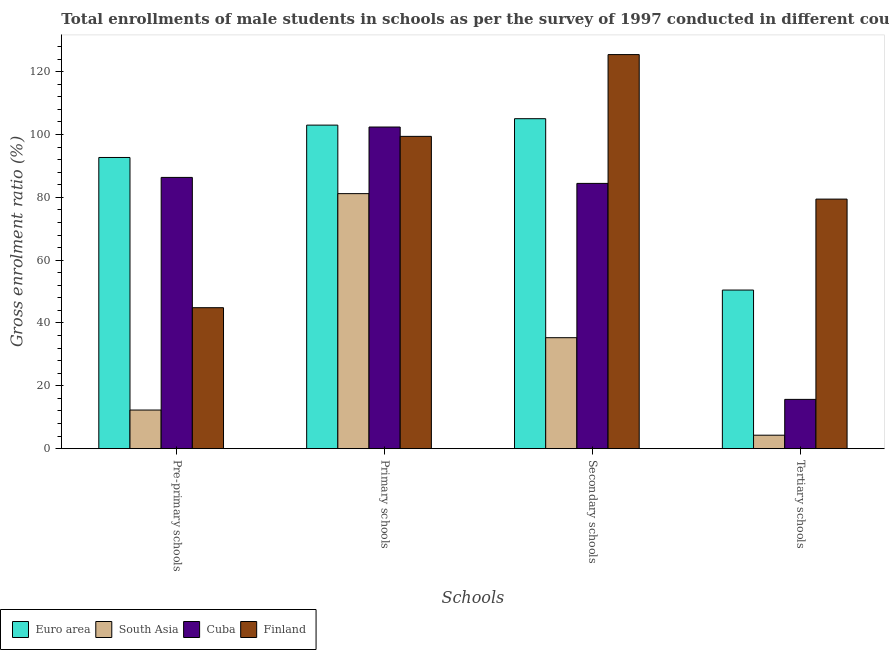Are the number of bars per tick equal to the number of legend labels?
Keep it short and to the point. Yes. Are the number of bars on each tick of the X-axis equal?
Offer a very short reply. Yes. How many bars are there on the 3rd tick from the right?
Offer a very short reply. 4. What is the label of the 4th group of bars from the left?
Keep it short and to the point. Tertiary schools. What is the gross enrolment ratio(male) in tertiary schools in Cuba?
Your answer should be compact. 15.69. Across all countries, what is the maximum gross enrolment ratio(male) in secondary schools?
Make the answer very short. 125.43. Across all countries, what is the minimum gross enrolment ratio(male) in primary schools?
Offer a terse response. 81.18. What is the total gross enrolment ratio(male) in pre-primary schools in the graph?
Your answer should be very brief. 236.18. What is the difference between the gross enrolment ratio(male) in primary schools in Euro area and that in Cuba?
Your response must be concise. 0.61. What is the difference between the gross enrolment ratio(male) in tertiary schools in Finland and the gross enrolment ratio(male) in primary schools in South Asia?
Provide a short and direct response. -1.74. What is the average gross enrolment ratio(male) in pre-primary schools per country?
Provide a short and direct response. 59.05. What is the difference between the gross enrolment ratio(male) in secondary schools and gross enrolment ratio(male) in primary schools in Euro area?
Provide a succinct answer. 2.04. What is the ratio of the gross enrolment ratio(male) in secondary schools in Finland to that in Cuba?
Make the answer very short. 1.49. Is the difference between the gross enrolment ratio(male) in secondary schools in Finland and South Asia greater than the difference between the gross enrolment ratio(male) in primary schools in Finland and South Asia?
Ensure brevity in your answer.  Yes. What is the difference between the highest and the second highest gross enrolment ratio(male) in secondary schools?
Offer a very short reply. 20.41. What is the difference between the highest and the lowest gross enrolment ratio(male) in secondary schools?
Provide a short and direct response. 90.11. Is the sum of the gross enrolment ratio(male) in tertiary schools in South Asia and Finland greater than the maximum gross enrolment ratio(male) in primary schools across all countries?
Ensure brevity in your answer.  No. Is it the case that in every country, the sum of the gross enrolment ratio(male) in secondary schools and gross enrolment ratio(male) in pre-primary schools is greater than the sum of gross enrolment ratio(male) in primary schools and gross enrolment ratio(male) in tertiary schools?
Provide a succinct answer. No. What does the 3rd bar from the left in Pre-primary schools represents?
Provide a short and direct response. Cuba. What does the 2nd bar from the right in Secondary schools represents?
Provide a succinct answer. Cuba. Are all the bars in the graph horizontal?
Your answer should be compact. No. How many countries are there in the graph?
Ensure brevity in your answer.  4. What is the difference between two consecutive major ticks on the Y-axis?
Your answer should be very brief. 20. Does the graph contain any zero values?
Give a very brief answer. No. Where does the legend appear in the graph?
Keep it short and to the point. Bottom left. How many legend labels are there?
Provide a short and direct response. 4. How are the legend labels stacked?
Your answer should be compact. Horizontal. What is the title of the graph?
Your response must be concise. Total enrollments of male students in schools as per the survey of 1997 conducted in different countries. What is the label or title of the X-axis?
Your answer should be very brief. Schools. What is the label or title of the Y-axis?
Your response must be concise. Gross enrolment ratio (%). What is the Gross enrolment ratio (%) of Euro area in Pre-primary schools?
Give a very brief answer. 92.68. What is the Gross enrolment ratio (%) of South Asia in Pre-primary schools?
Your answer should be compact. 12.29. What is the Gross enrolment ratio (%) of Cuba in Pre-primary schools?
Offer a terse response. 86.34. What is the Gross enrolment ratio (%) in Finland in Pre-primary schools?
Provide a short and direct response. 44.87. What is the Gross enrolment ratio (%) in Euro area in Primary schools?
Offer a terse response. 102.98. What is the Gross enrolment ratio (%) of South Asia in Primary schools?
Your response must be concise. 81.18. What is the Gross enrolment ratio (%) in Cuba in Primary schools?
Offer a terse response. 102.38. What is the Gross enrolment ratio (%) of Finland in Primary schools?
Provide a succinct answer. 99.4. What is the Gross enrolment ratio (%) of Euro area in Secondary schools?
Provide a succinct answer. 105.03. What is the Gross enrolment ratio (%) in South Asia in Secondary schools?
Offer a terse response. 35.32. What is the Gross enrolment ratio (%) in Cuba in Secondary schools?
Offer a very short reply. 84.43. What is the Gross enrolment ratio (%) in Finland in Secondary schools?
Your response must be concise. 125.43. What is the Gross enrolment ratio (%) of Euro area in Tertiary schools?
Ensure brevity in your answer.  50.49. What is the Gross enrolment ratio (%) in South Asia in Tertiary schools?
Give a very brief answer. 4.29. What is the Gross enrolment ratio (%) of Cuba in Tertiary schools?
Provide a succinct answer. 15.69. What is the Gross enrolment ratio (%) of Finland in Tertiary schools?
Give a very brief answer. 79.43. Across all Schools, what is the maximum Gross enrolment ratio (%) of Euro area?
Offer a very short reply. 105.03. Across all Schools, what is the maximum Gross enrolment ratio (%) in South Asia?
Ensure brevity in your answer.  81.18. Across all Schools, what is the maximum Gross enrolment ratio (%) in Cuba?
Provide a short and direct response. 102.38. Across all Schools, what is the maximum Gross enrolment ratio (%) in Finland?
Your answer should be very brief. 125.43. Across all Schools, what is the minimum Gross enrolment ratio (%) in Euro area?
Your response must be concise. 50.49. Across all Schools, what is the minimum Gross enrolment ratio (%) in South Asia?
Provide a short and direct response. 4.29. Across all Schools, what is the minimum Gross enrolment ratio (%) in Cuba?
Give a very brief answer. 15.69. Across all Schools, what is the minimum Gross enrolment ratio (%) in Finland?
Offer a terse response. 44.87. What is the total Gross enrolment ratio (%) of Euro area in the graph?
Provide a succinct answer. 351.17. What is the total Gross enrolment ratio (%) of South Asia in the graph?
Ensure brevity in your answer.  133.09. What is the total Gross enrolment ratio (%) in Cuba in the graph?
Ensure brevity in your answer.  288.83. What is the total Gross enrolment ratio (%) in Finland in the graph?
Your answer should be very brief. 349.14. What is the difference between the Gross enrolment ratio (%) of Euro area in Pre-primary schools and that in Primary schools?
Your response must be concise. -10.3. What is the difference between the Gross enrolment ratio (%) of South Asia in Pre-primary schools and that in Primary schools?
Give a very brief answer. -68.88. What is the difference between the Gross enrolment ratio (%) of Cuba in Pre-primary schools and that in Primary schools?
Your response must be concise. -16.04. What is the difference between the Gross enrolment ratio (%) in Finland in Pre-primary schools and that in Primary schools?
Offer a terse response. -54.53. What is the difference between the Gross enrolment ratio (%) in Euro area in Pre-primary schools and that in Secondary schools?
Your response must be concise. -12.34. What is the difference between the Gross enrolment ratio (%) of South Asia in Pre-primary schools and that in Secondary schools?
Offer a very short reply. -23.03. What is the difference between the Gross enrolment ratio (%) of Cuba in Pre-primary schools and that in Secondary schools?
Ensure brevity in your answer.  1.91. What is the difference between the Gross enrolment ratio (%) of Finland in Pre-primary schools and that in Secondary schools?
Provide a succinct answer. -80.56. What is the difference between the Gross enrolment ratio (%) in Euro area in Pre-primary schools and that in Tertiary schools?
Provide a short and direct response. 42.2. What is the difference between the Gross enrolment ratio (%) of South Asia in Pre-primary schools and that in Tertiary schools?
Offer a very short reply. 8. What is the difference between the Gross enrolment ratio (%) in Cuba in Pre-primary schools and that in Tertiary schools?
Offer a terse response. 70.65. What is the difference between the Gross enrolment ratio (%) in Finland in Pre-primary schools and that in Tertiary schools?
Ensure brevity in your answer.  -34.56. What is the difference between the Gross enrolment ratio (%) of Euro area in Primary schools and that in Secondary schools?
Keep it short and to the point. -2.04. What is the difference between the Gross enrolment ratio (%) in South Asia in Primary schools and that in Secondary schools?
Offer a very short reply. 45.85. What is the difference between the Gross enrolment ratio (%) of Cuba in Primary schools and that in Secondary schools?
Give a very brief answer. 17.94. What is the difference between the Gross enrolment ratio (%) of Finland in Primary schools and that in Secondary schools?
Ensure brevity in your answer.  -26.03. What is the difference between the Gross enrolment ratio (%) in Euro area in Primary schools and that in Tertiary schools?
Make the answer very short. 52.5. What is the difference between the Gross enrolment ratio (%) of South Asia in Primary schools and that in Tertiary schools?
Ensure brevity in your answer.  76.88. What is the difference between the Gross enrolment ratio (%) of Cuba in Primary schools and that in Tertiary schools?
Make the answer very short. 86.69. What is the difference between the Gross enrolment ratio (%) in Finland in Primary schools and that in Tertiary schools?
Give a very brief answer. 19.97. What is the difference between the Gross enrolment ratio (%) of Euro area in Secondary schools and that in Tertiary schools?
Ensure brevity in your answer.  54.54. What is the difference between the Gross enrolment ratio (%) in South Asia in Secondary schools and that in Tertiary schools?
Keep it short and to the point. 31.03. What is the difference between the Gross enrolment ratio (%) of Cuba in Secondary schools and that in Tertiary schools?
Make the answer very short. 68.74. What is the difference between the Gross enrolment ratio (%) of Finland in Secondary schools and that in Tertiary schools?
Give a very brief answer. 46. What is the difference between the Gross enrolment ratio (%) in Euro area in Pre-primary schools and the Gross enrolment ratio (%) in South Asia in Primary schools?
Offer a very short reply. 11.51. What is the difference between the Gross enrolment ratio (%) of Euro area in Pre-primary schools and the Gross enrolment ratio (%) of Cuba in Primary schools?
Offer a terse response. -9.69. What is the difference between the Gross enrolment ratio (%) of Euro area in Pre-primary schools and the Gross enrolment ratio (%) of Finland in Primary schools?
Ensure brevity in your answer.  -6.72. What is the difference between the Gross enrolment ratio (%) in South Asia in Pre-primary schools and the Gross enrolment ratio (%) in Cuba in Primary schools?
Your response must be concise. -90.08. What is the difference between the Gross enrolment ratio (%) in South Asia in Pre-primary schools and the Gross enrolment ratio (%) in Finland in Primary schools?
Ensure brevity in your answer.  -87.11. What is the difference between the Gross enrolment ratio (%) in Cuba in Pre-primary schools and the Gross enrolment ratio (%) in Finland in Primary schools?
Give a very brief answer. -13.06. What is the difference between the Gross enrolment ratio (%) in Euro area in Pre-primary schools and the Gross enrolment ratio (%) in South Asia in Secondary schools?
Your response must be concise. 57.36. What is the difference between the Gross enrolment ratio (%) in Euro area in Pre-primary schools and the Gross enrolment ratio (%) in Cuba in Secondary schools?
Provide a succinct answer. 8.25. What is the difference between the Gross enrolment ratio (%) in Euro area in Pre-primary schools and the Gross enrolment ratio (%) in Finland in Secondary schools?
Offer a terse response. -32.75. What is the difference between the Gross enrolment ratio (%) of South Asia in Pre-primary schools and the Gross enrolment ratio (%) of Cuba in Secondary schools?
Give a very brief answer. -72.14. What is the difference between the Gross enrolment ratio (%) in South Asia in Pre-primary schools and the Gross enrolment ratio (%) in Finland in Secondary schools?
Provide a short and direct response. -113.14. What is the difference between the Gross enrolment ratio (%) of Cuba in Pre-primary schools and the Gross enrolment ratio (%) of Finland in Secondary schools?
Provide a succinct answer. -39.1. What is the difference between the Gross enrolment ratio (%) in Euro area in Pre-primary schools and the Gross enrolment ratio (%) in South Asia in Tertiary schools?
Make the answer very short. 88.39. What is the difference between the Gross enrolment ratio (%) in Euro area in Pre-primary schools and the Gross enrolment ratio (%) in Cuba in Tertiary schools?
Give a very brief answer. 77. What is the difference between the Gross enrolment ratio (%) of Euro area in Pre-primary schools and the Gross enrolment ratio (%) of Finland in Tertiary schools?
Your response must be concise. 13.25. What is the difference between the Gross enrolment ratio (%) in South Asia in Pre-primary schools and the Gross enrolment ratio (%) in Cuba in Tertiary schools?
Keep it short and to the point. -3.39. What is the difference between the Gross enrolment ratio (%) in South Asia in Pre-primary schools and the Gross enrolment ratio (%) in Finland in Tertiary schools?
Make the answer very short. -67.14. What is the difference between the Gross enrolment ratio (%) in Cuba in Pre-primary schools and the Gross enrolment ratio (%) in Finland in Tertiary schools?
Give a very brief answer. 6.9. What is the difference between the Gross enrolment ratio (%) in Euro area in Primary schools and the Gross enrolment ratio (%) in South Asia in Secondary schools?
Ensure brevity in your answer.  67.66. What is the difference between the Gross enrolment ratio (%) in Euro area in Primary schools and the Gross enrolment ratio (%) in Cuba in Secondary schools?
Your answer should be compact. 18.55. What is the difference between the Gross enrolment ratio (%) in Euro area in Primary schools and the Gross enrolment ratio (%) in Finland in Secondary schools?
Give a very brief answer. -22.45. What is the difference between the Gross enrolment ratio (%) in South Asia in Primary schools and the Gross enrolment ratio (%) in Cuba in Secondary schools?
Ensure brevity in your answer.  -3.25. What is the difference between the Gross enrolment ratio (%) of South Asia in Primary schools and the Gross enrolment ratio (%) of Finland in Secondary schools?
Your response must be concise. -44.26. What is the difference between the Gross enrolment ratio (%) of Cuba in Primary schools and the Gross enrolment ratio (%) of Finland in Secondary schools?
Give a very brief answer. -23.06. What is the difference between the Gross enrolment ratio (%) in Euro area in Primary schools and the Gross enrolment ratio (%) in South Asia in Tertiary schools?
Make the answer very short. 98.69. What is the difference between the Gross enrolment ratio (%) in Euro area in Primary schools and the Gross enrolment ratio (%) in Cuba in Tertiary schools?
Offer a terse response. 87.29. What is the difference between the Gross enrolment ratio (%) in Euro area in Primary schools and the Gross enrolment ratio (%) in Finland in Tertiary schools?
Ensure brevity in your answer.  23.55. What is the difference between the Gross enrolment ratio (%) in South Asia in Primary schools and the Gross enrolment ratio (%) in Cuba in Tertiary schools?
Keep it short and to the point. 65.49. What is the difference between the Gross enrolment ratio (%) of South Asia in Primary schools and the Gross enrolment ratio (%) of Finland in Tertiary schools?
Your response must be concise. 1.74. What is the difference between the Gross enrolment ratio (%) of Cuba in Primary schools and the Gross enrolment ratio (%) of Finland in Tertiary schools?
Keep it short and to the point. 22.94. What is the difference between the Gross enrolment ratio (%) in Euro area in Secondary schools and the Gross enrolment ratio (%) in South Asia in Tertiary schools?
Your answer should be very brief. 100.73. What is the difference between the Gross enrolment ratio (%) in Euro area in Secondary schools and the Gross enrolment ratio (%) in Cuba in Tertiary schools?
Your answer should be compact. 89.34. What is the difference between the Gross enrolment ratio (%) of Euro area in Secondary schools and the Gross enrolment ratio (%) of Finland in Tertiary schools?
Provide a succinct answer. 25.59. What is the difference between the Gross enrolment ratio (%) of South Asia in Secondary schools and the Gross enrolment ratio (%) of Cuba in Tertiary schools?
Your answer should be very brief. 19.63. What is the difference between the Gross enrolment ratio (%) in South Asia in Secondary schools and the Gross enrolment ratio (%) in Finland in Tertiary schools?
Your answer should be compact. -44.11. What is the difference between the Gross enrolment ratio (%) in Cuba in Secondary schools and the Gross enrolment ratio (%) in Finland in Tertiary schools?
Your answer should be compact. 5. What is the average Gross enrolment ratio (%) in Euro area per Schools?
Offer a very short reply. 87.79. What is the average Gross enrolment ratio (%) in South Asia per Schools?
Provide a succinct answer. 33.27. What is the average Gross enrolment ratio (%) in Cuba per Schools?
Provide a succinct answer. 72.21. What is the average Gross enrolment ratio (%) in Finland per Schools?
Your answer should be compact. 87.28. What is the difference between the Gross enrolment ratio (%) of Euro area and Gross enrolment ratio (%) of South Asia in Pre-primary schools?
Keep it short and to the point. 80.39. What is the difference between the Gross enrolment ratio (%) in Euro area and Gross enrolment ratio (%) in Cuba in Pre-primary schools?
Your answer should be very brief. 6.35. What is the difference between the Gross enrolment ratio (%) in Euro area and Gross enrolment ratio (%) in Finland in Pre-primary schools?
Offer a very short reply. 47.81. What is the difference between the Gross enrolment ratio (%) in South Asia and Gross enrolment ratio (%) in Cuba in Pre-primary schools?
Your answer should be compact. -74.04. What is the difference between the Gross enrolment ratio (%) in South Asia and Gross enrolment ratio (%) in Finland in Pre-primary schools?
Your answer should be very brief. -32.57. What is the difference between the Gross enrolment ratio (%) of Cuba and Gross enrolment ratio (%) of Finland in Pre-primary schools?
Provide a succinct answer. 41.47. What is the difference between the Gross enrolment ratio (%) of Euro area and Gross enrolment ratio (%) of South Asia in Primary schools?
Keep it short and to the point. 21.81. What is the difference between the Gross enrolment ratio (%) of Euro area and Gross enrolment ratio (%) of Cuba in Primary schools?
Your response must be concise. 0.61. What is the difference between the Gross enrolment ratio (%) of Euro area and Gross enrolment ratio (%) of Finland in Primary schools?
Your response must be concise. 3.58. What is the difference between the Gross enrolment ratio (%) in South Asia and Gross enrolment ratio (%) in Cuba in Primary schools?
Offer a very short reply. -21.2. What is the difference between the Gross enrolment ratio (%) of South Asia and Gross enrolment ratio (%) of Finland in Primary schools?
Your answer should be compact. -18.22. What is the difference between the Gross enrolment ratio (%) of Cuba and Gross enrolment ratio (%) of Finland in Primary schools?
Your answer should be very brief. 2.97. What is the difference between the Gross enrolment ratio (%) in Euro area and Gross enrolment ratio (%) in South Asia in Secondary schools?
Offer a very short reply. 69.7. What is the difference between the Gross enrolment ratio (%) in Euro area and Gross enrolment ratio (%) in Cuba in Secondary schools?
Provide a short and direct response. 20.59. What is the difference between the Gross enrolment ratio (%) in Euro area and Gross enrolment ratio (%) in Finland in Secondary schools?
Offer a terse response. -20.41. What is the difference between the Gross enrolment ratio (%) in South Asia and Gross enrolment ratio (%) in Cuba in Secondary schools?
Offer a terse response. -49.11. What is the difference between the Gross enrolment ratio (%) of South Asia and Gross enrolment ratio (%) of Finland in Secondary schools?
Your answer should be compact. -90.11. What is the difference between the Gross enrolment ratio (%) of Cuba and Gross enrolment ratio (%) of Finland in Secondary schools?
Your answer should be compact. -41. What is the difference between the Gross enrolment ratio (%) of Euro area and Gross enrolment ratio (%) of South Asia in Tertiary schools?
Offer a terse response. 46.19. What is the difference between the Gross enrolment ratio (%) in Euro area and Gross enrolment ratio (%) in Cuba in Tertiary schools?
Offer a terse response. 34.8. What is the difference between the Gross enrolment ratio (%) of Euro area and Gross enrolment ratio (%) of Finland in Tertiary schools?
Make the answer very short. -28.95. What is the difference between the Gross enrolment ratio (%) of South Asia and Gross enrolment ratio (%) of Cuba in Tertiary schools?
Offer a terse response. -11.4. What is the difference between the Gross enrolment ratio (%) of South Asia and Gross enrolment ratio (%) of Finland in Tertiary schools?
Offer a very short reply. -75.14. What is the difference between the Gross enrolment ratio (%) of Cuba and Gross enrolment ratio (%) of Finland in Tertiary schools?
Give a very brief answer. -63.75. What is the ratio of the Gross enrolment ratio (%) in South Asia in Pre-primary schools to that in Primary schools?
Provide a succinct answer. 0.15. What is the ratio of the Gross enrolment ratio (%) of Cuba in Pre-primary schools to that in Primary schools?
Your answer should be very brief. 0.84. What is the ratio of the Gross enrolment ratio (%) in Finland in Pre-primary schools to that in Primary schools?
Provide a succinct answer. 0.45. What is the ratio of the Gross enrolment ratio (%) in Euro area in Pre-primary schools to that in Secondary schools?
Provide a succinct answer. 0.88. What is the ratio of the Gross enrolment ratio (%) in South Asia in Pre-primary schools to that in Secondary schools?
Your answer should be very brief. 0.35. What is the ratio of the Gross enrolment ratio (%) in Cuba in Pre-primary schools to that in Secondary schools?
Keep it short and to the point. 1.02. What is the ratio of the Gross enrolment ratio (%) in Finland in Pre-primary schools to that in Secondary schools?
Keep it short and to the point. 0.36. What is the ratio of the Gross enrolment ratio (%) of Euro area in Pre-primary schools to that in Tertiary schools?
Provide a short and direct response. 1.84. What is the ratio of the Gross enrolment ratio (%) in South Asia in Pre-primary schools to that in Tertiary schools?
Ensure brevity in your answer.  2.86. What is the ratio of the Gross enrolment ratio (%) of Cuba in Pre-primary schools to that in Tertiary schools?
Provide a short and direct response. 5.5. What is the ratio of the Gross enrolment ratio (%) of Finland in Pre-primary schools to that in Tertiary schools?
Your answer should be very brief. 0.56. What is the ratio of the Gross enrolment ratio (%) in Euro area in Primary schools to that in Secondary schools?
Offer a terse response. 0.98. What is the ratio of the Gross enrolment ratio (%) in South Asia in Primary schools to that in Secondary schools?
Make the answer very short. 2.3. What is the ratio of the Gross enrolment ratio (%) of Cuba in Primary schools to that in Secondary schools?
Make the answer very short. 1.21. What is the ratio of the Gross enrolment ratio (%) in Finland in Primary schools to that in Secondary schools?
Ensure brevity in your answer.  0.79. What is the ratio of the Gross enrolment ratio (%) of Euro area in Primary schools to that in Tertiary schools?
Keep it short and to the point. 2.04. What is the ratio of the Gross enrolment ratio (%) in South Asia in Primary schools to that in Tertiary schools?
Make the answer very short. 18.91. What is the ratio of the Gross enrolment ratio (%) of Cuba in Primary schools to that in Tertiary schools?
Your response must be concise. 6.53. What is the ratio of the Gross enrolment ratio (%) of Finland in Primary schools to that in Tertiary schools?
Make the answer very short. 1.25. What is the ratio of the Gross enrolment ratio (%) in Euro area in Secondary schools to that in Tertiary schools?
Give a very brief answer. 2.08. What is the ratio of the Gross enrolment ratio (%) in South Asia in Secondary schools to that in Tertiary schools?
Ensure brevity in your answer.  8.23. What is the ratio of the Gross enrolment ratio (%) of Cuba in Secondary schools to that in Tertiary schools?
Provide a short and direct response. 5.38. What is the ratio of the Gross enrolment ratio (%) in Finland in Secondary schools to that in Tertiary schools?
Ensure brevity in your answer.  1.58. What is the difference between the highest and the second highest Gross enrolment ratio (%) of Euro area?
Make the answer very short. 2.04. What is the difference between the highest and the second highest Gross enrolment ratio (%) of South Asia?
Give a very brief answer. 45.85. What is the difference between the highest and the second highest Gross enrolment ratio (%) in Cuba?
Offer a very short reply. 16.04. What is the difference between the highest and the second highest Gross enrolment ratio (%) of Finland?
Your answer should be compact. 26.03. What is the difference between the highest and the lowest Gross enrolment ratio (%) in Euro area?
Your response must be concise. 54.54. What is the difference between the highest and the lowest Gross enrolment ratio (%) of South Asia?
Keep it short and to the point. 76.88. What is the difference between the highest and the lowest Gross enrolment ratio (%) in Cuba?
Provide a succinct answer. 86.69. What is the difference between the highest and the lowest Gross enrolment ratio (%) in Finland?
Your response must be concise. 80.56. 